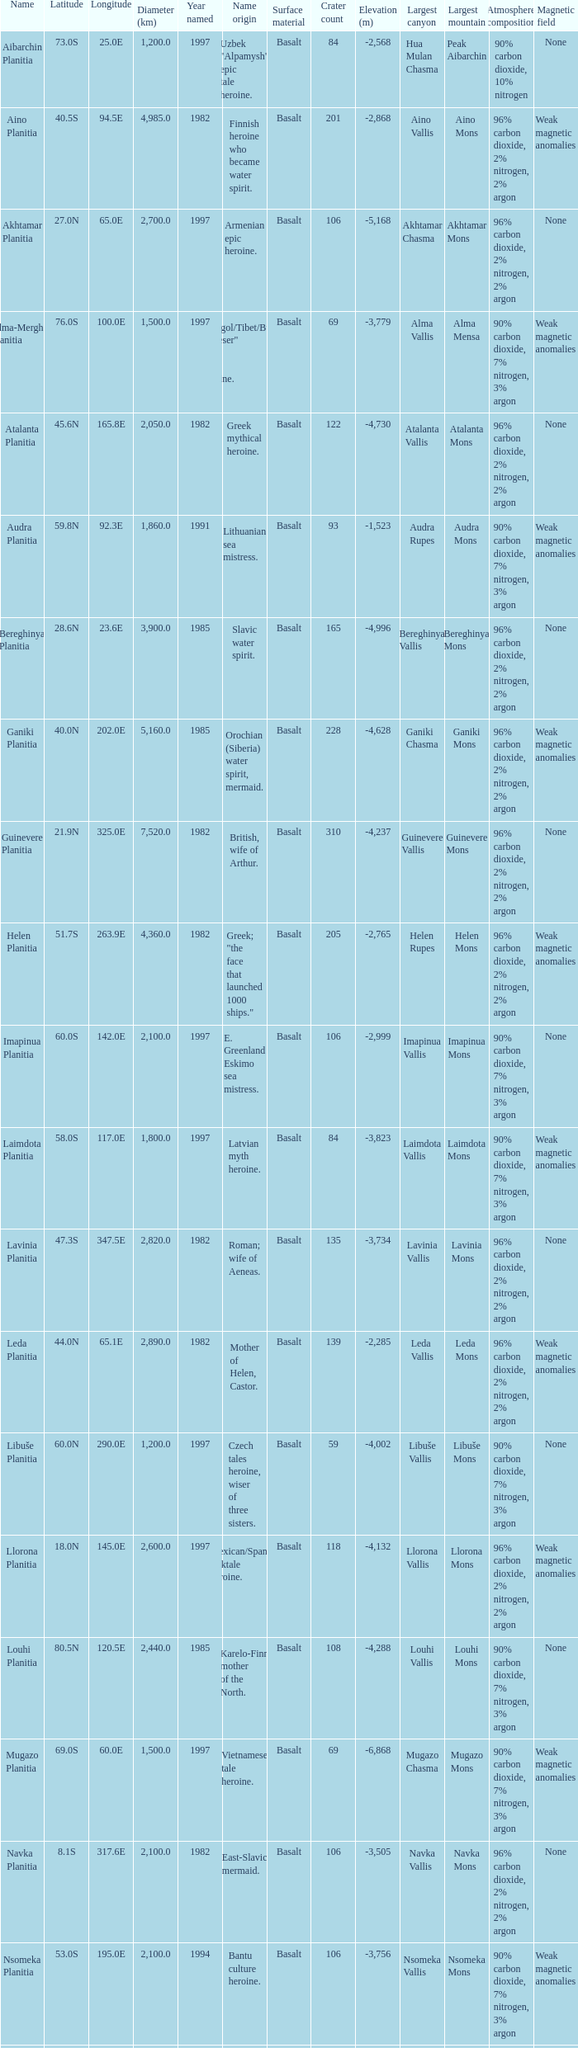What is the diameter (km) of the feature of latitude 23.0s 3000.0. 